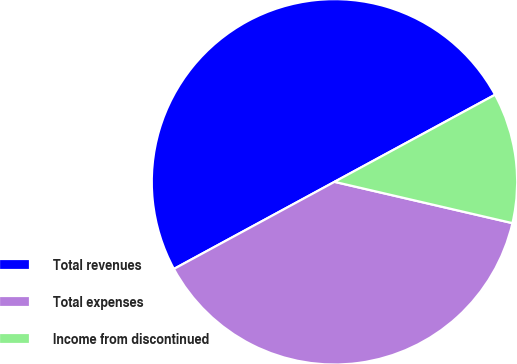<chart> <loc_0><loc_0><loc_500><loc_500><pie_chart><fcel>Total revenues<fcel>Total expenses<fcel>Income from discontinued<nl><fcel>50.0%<fcel>38.46%<fcel>11.54%<nl></chart> 